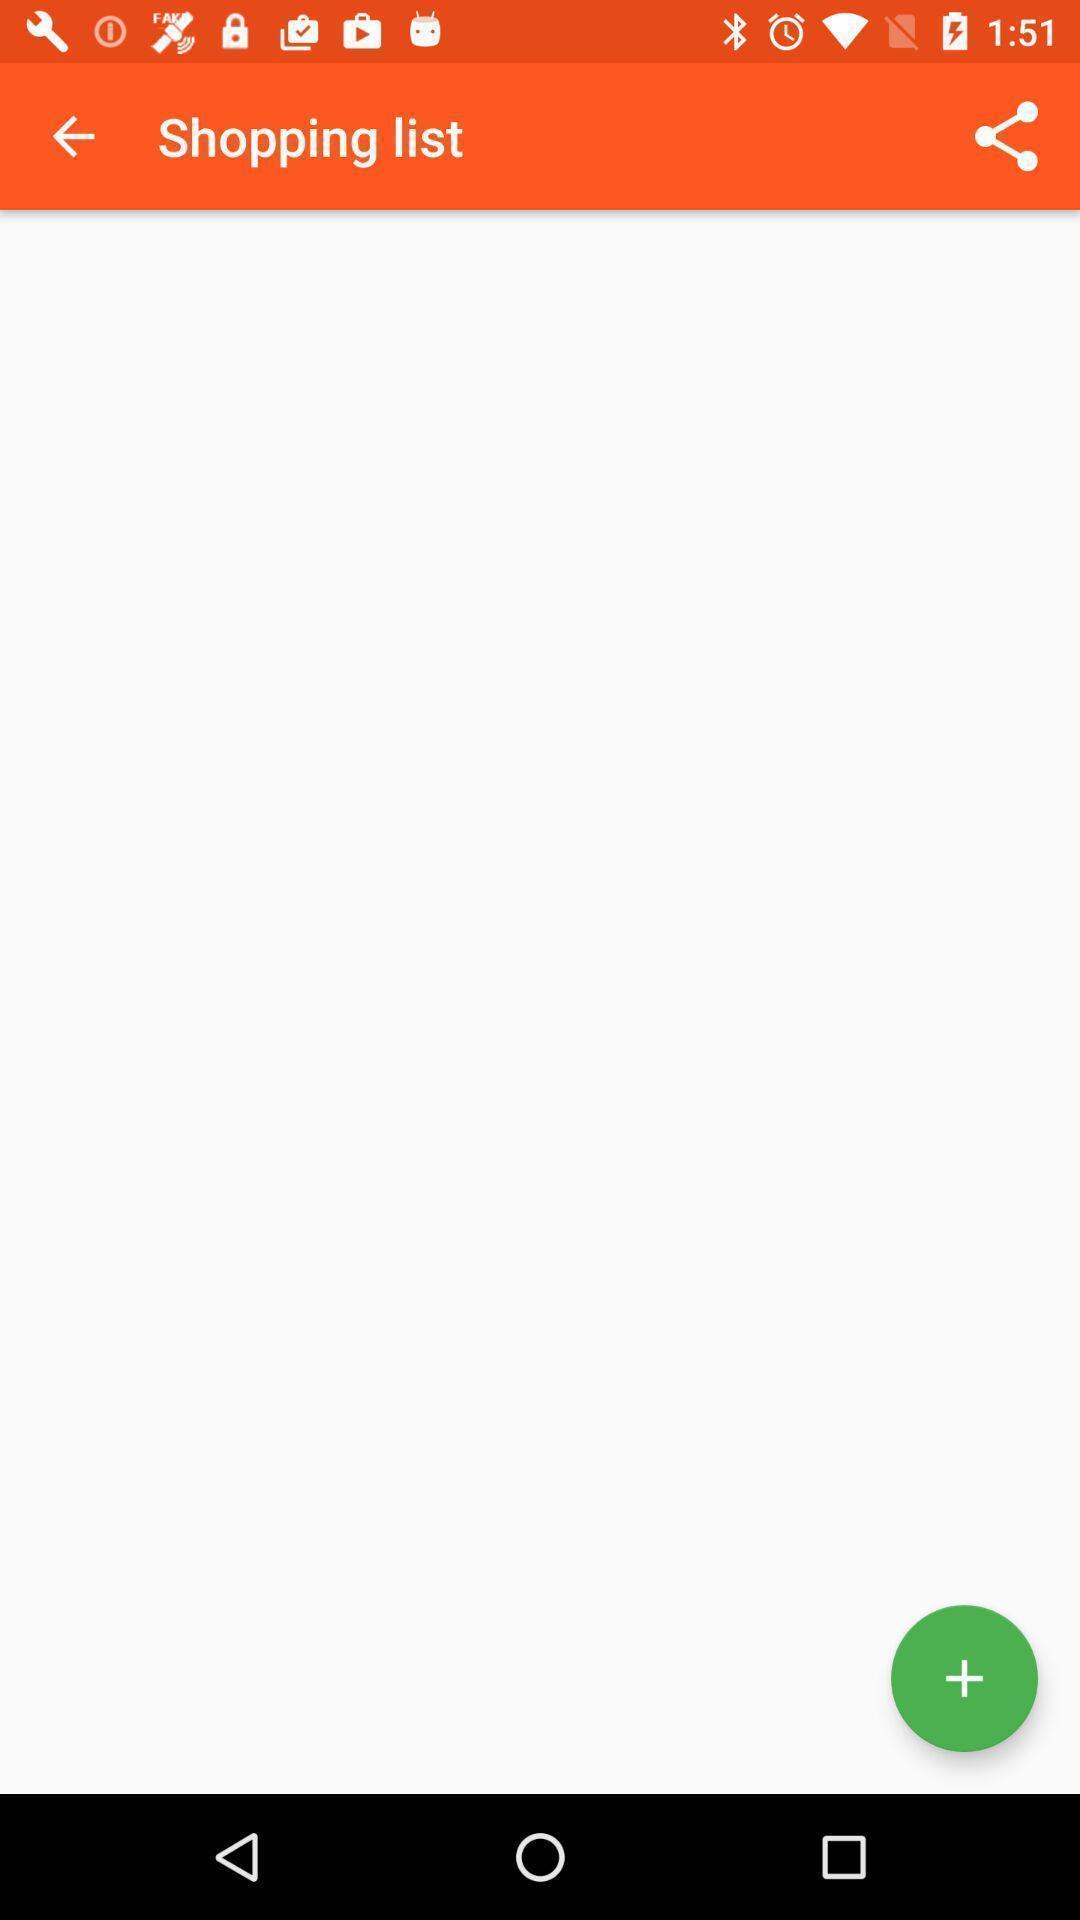Describe the content in this image. Shopping app displayed empty page of a shopping list. 